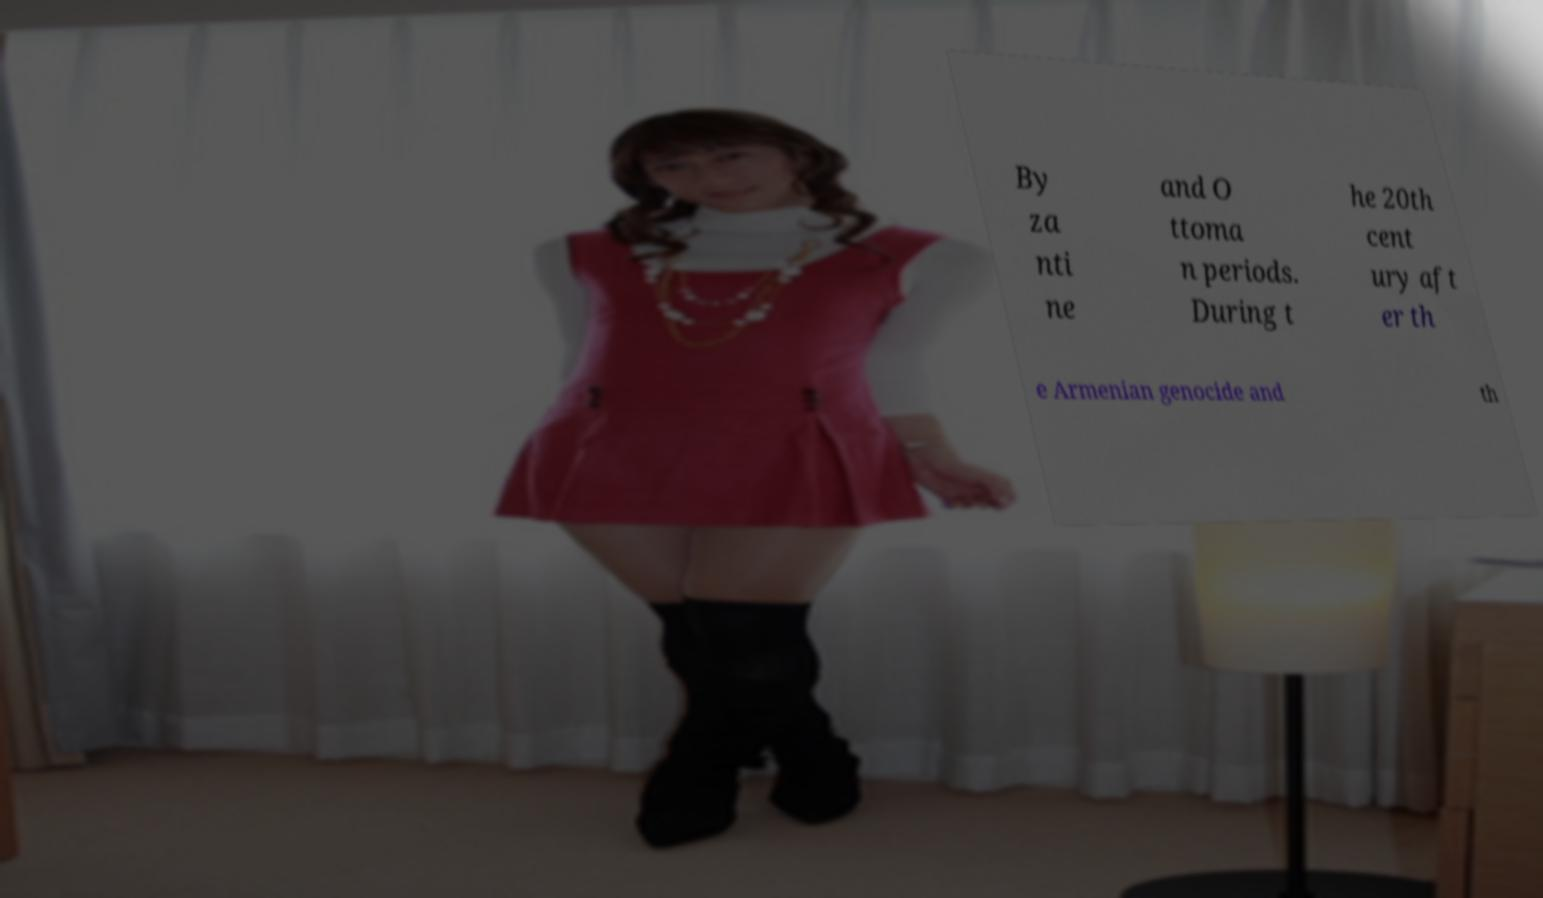Can you accurately transcribe the text from the provided image for me? By za nti ne and O ttoma n periods. During t he 20th cent ury aft er th e Armenian genocide and th 